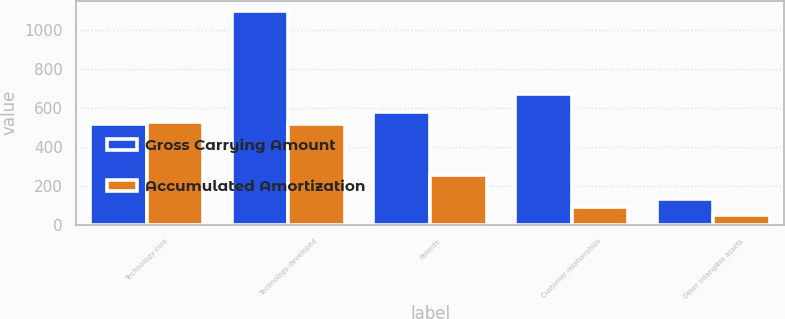Convert chart. <chart><loc_0><loc_0><loc_500><loc_500><stacked_bar_chart><ecel><fcel>Technology-core<fcel>Technology-developed<fcel>Patents<fcel>Customer relationships<fcel>Other intangible assets<nl><fcel>Gross Carrying Amount<fcel>515<fcel>1096<fcel>579<fcel>674<fcel>132<nl><fcel>Accumulated Amortization<fcel>526<fcel>515<fcel>257<fcel>91<fcel>51<nl></chart> 